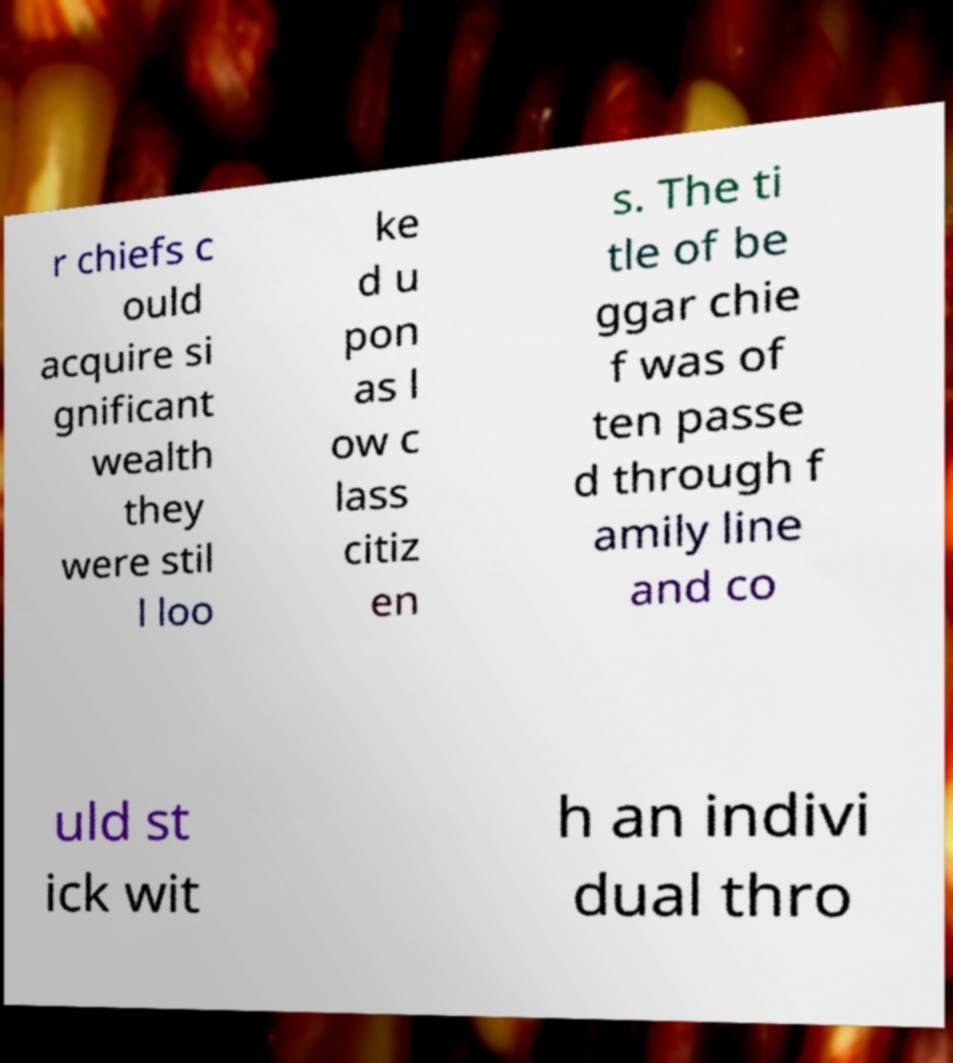Could you extract and type out the text from this image? r chiefs c ould acquire si gnificant wealth they were stil l loo ke d u pon as l ow c lass citiz en s. The ti tle of be ggar chie f was of ten passe d through f amily line and co uld st ick wit h an indivi dual thro 